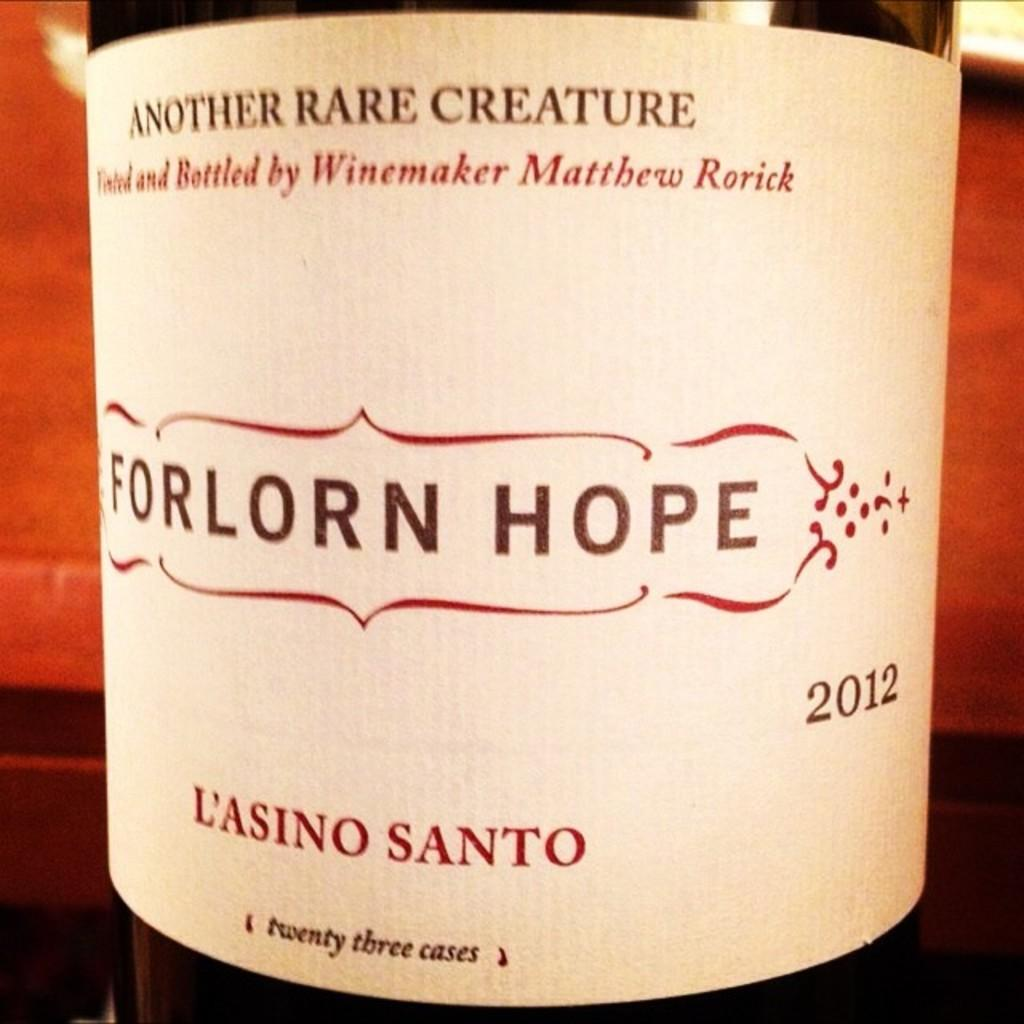<image>
Provide a brief description of the given image. bottle of wime called forlon hope from 2012 